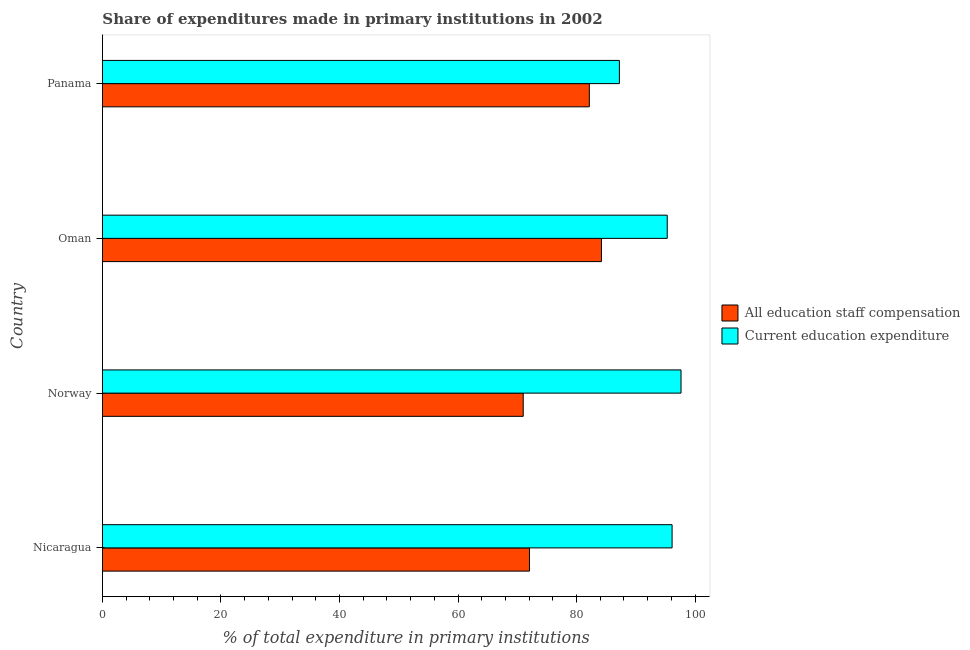How many different coloured bars are there?
Provide a succinct answer. 2. How many groups of bars are there?
Ensure brevity in your answer.  4. How many bars are there on the 4th tick from the top?
Your answer should be compact. 2. What is the label of the 2nd group of bars from the top?
Provide a succinct answer. Oman. What is the expenditure in education in Oman?
Ensure brevity in your answer.  95.31. Across all countries, what is the maximum expenditure in education?
Provide a succinct answer. 97.64. Across all countries, what is the minimum expenditure in staff compensation?
Keep it short and to the point. 71.01. In which country was the expenditure in education minimum?
Your answer should be very brief. Panama. What is the total expenditure in education in the graph?
Ensure brevity in your answer.  376.31. What is the difference between the expenditure in education in Nicaragua and that in Norway?
Offer a terse response. -1.51. What is the difference between the expenditure in education in Panama and the expenditure in staff compensation in Oman?
Provide a short and direct response. 3.03. What is the average expenditure in education per country?
Make the answer very short. 94.08. What is the difference between the expenditure in staff compensation and expenditure in education in Norway?
Your answer should be very brief. -26.63. In how many countries, is the expenditure in education greater than 92 %?
Your response must be concise. 3. What is the ratio of the expenditure in staff compensation in Nicaragua to that in Norway?
Make the answer very short. 1.01. Is the expenditure in staff compensation in Nicaragua less than that in Panama?
Provide a succinct answer. Yes. What is the difference between the highest and the second highest expenditure in education?
Ensure brevity in your answer.  1.51. Is the sum of the expenditure in education in Oman and Panama greater than the maximum expenditure in staff compensation across all countries?
Give a very brief answer. Yes. What does the 1st bar from the top in Panama represents?
Your answer should be very brief. Current education expenditure. What does the 1st bar from the bottom in Norway represents?
Keep it short and to the point. All education staff compensation. Are all the bars in the graph horizontal?
Give a very brief answer. Yes. What is the difference between two consecutive major ticks on the X-axis?
Give a very brief answer. 20. Are the values on the major ticks of X-axis written in scientific E-notation?
Your response must be concise. No. Does the graph contain any zero values?
Ensure brevity in your answer.  No. Does the graph contain grids?
Provide a short and direct response. No. What is the title of the graph?
Your answer should be very brief. Share of expenditures made in primary institutions in 2002. Does "Health Care" appear as one of the legend labels in the graph?
Give a very brief answer. No. What is the label or title of the X-axis?
Offer a terse response. % of total expenditure in primary institutions. What is the % of total expenditure in primary institutions of All education staff compensation in Nicaragua?
Offer a very short reply. 72.06. What is the % of total expenditure in primary institutions of Current education expenditure in Nicaragua?
Keep it short and to the point. 96.13. What is the % of total expenditure in primary institutions in All education staff compensation in Norway?
Provide a short and direct response. 71.01. What is the % of total expenditure in primary institutions in Current education expenditure in Norway?
Your response must be concise. 97.64. What is the % of total expenditure in primary institutions in All education staff compensation in Oman?
Keep it short and to the point. 84.21. What is the % of total expenditure in primary institutions of Current education expenditure in Oman?
Ensure brevity in your answer.  95.31. What is the % of total expenditure in primary institutions of All education staff compensation in Panama?
Keep it short and to the point. 82.16. What is the % of total expenditure in primary institutions in Current education expenditure in Panama?
Provide a succinct answer. 87.24. Across all countries, what is the maximum % of total expenditure in primary institutions of All education staff compensation?
Your response must be concise. 84.21. Across all countries, what is the maximum % of total expenditure in primary institutions of Current education expenditure?
Make the answer very short. 97.64. Across all countries, what is the minimum % of total expenditure in primary institutions of All education staff compensation?
Your answer should be compact. 71.01. Across all countries, what is the minimum % of total expenditure in primary institutions in Current education expenditure?
Your answer should be very brief. 87.24. What is the total % of total expenditure in primary institutions in All education staff compensation in the graph?
Give a very brief answer. 309.44. What is the total % of total expenditure in primary institutions in Current education expenditure in the graph?
Give a very brief answer. 376.31. What is the difference between the % of total expenditure in primary institutions in All education staff compensation in Nicaragua and that in Norway?
Keep it short and to the point. 1.05. What is the difference between the % of total expenditure in primary institutions in Current education expenditure in Nicaragua and that in Norway?
Keep it short and to the point. -1.51. What is the difference between the % of total expenditure in primary institutions in All education staff compensation in Nicaragua and that in Oman?
Make the answer very short. -12.15. What is the difference between the % of total expenditure in primary institutions of Current education expenditure in Nicaragua and that in Oman?
Give a very brief answer. 0.82. What is the difference between the % of total expenditure in primary institutions in All education staff compensation in Nicaragua and that in Panama?
Your answer should be compact. -10.1. What is the difference between the % of total expenditure in primary institutions of Current education expenditure in Nicaragua and that in Panama?
Make the answer very short. 8.9. What is the difference between the % of total expenditure in primary institutions of All education staff compensation in Norway and that in Oman?
Give a very brief answer. -13.2. What is the difference between the % of total expenditure in primary institutions in Current education expenditure in Norway and that in Oman?
Offer a terse response. 2.33. What is the difference between the % of total expenditure in primary institutions of All education staff compensation in Norway and that in Panama?
Offer a terse response. -11.16. What is the difference between the % of total expenditure in primary institutions of Current education expenditure in Norway and that in Panama?
Your answer should be very brief. 10.4. What is the difference between the % of total expenditure in primary institutions of All education staff compensation in Oman and that in Panama?
Give a very brief answer. 2.04. What is the difference between the % of total expenditure in primary institutions in Current education expenditure in Oman and that in Panama?
Keep it short and to the point. 8.07. What is the difference between the % of total expenditure in primary institutions in All education staff compensation in Nicaragua and the % of total expenditure in primary institutions in Current education expenditure in Norway?
Your response must be concise. -25.58. What is the difference between the % of total expenditure in primary institutions in All education staff compensation in Nicaragua and the % of total expenditure in primary institutions in Current education expenditure in Oman?
Give a very brief answer. -23.25. What is the difference between the % of total expenditure in primary institutions in All education staff compensation in Nicaragua and the % of total expenditure in primary institutions in Current education expenditure in Panama?
Your answer should be compact. -15.17. What is the difference between the % of total expenditure in primary institutions in All education staff compensation in Norway and the % of total expenditure in primary institutions in Current education expenditure in Oman?
Make the answer very short. -24.3. What is the difference between the % of total expenditure in primary institutions in All education staff compensation in Norway and the % of total expenditure in primary institutions in Current education expenditure in Panama?
Provide a succinct answer. -16.23. What is the difference between the % of total expenditure in primary institutions of All education staff compensation in Oman and the % of total expenditure in primary institutions of Current education expenditure in Panama?
Ensure brevity in your answer.  -3.03. What is the average % of total expenditure in primary institutions of All education staff compensation per country?
Your answer should be very brief. 77.36. What is the average % of total expenditure in primary institutions in Current education expenditure per country?
Your answer should be very brief. 94.08. What is the difference between the % of total expenditure in primary institutions of All education staff compensation and % of total expenditure in primary institutions of Current education expenditure in Nicaragua?
Provide a short and direct response. -24.07. What is the difference between the % of total expenditure in primary institutions in All education staff compensation and % of total expenditure in primary institutions in Current education expenditure in Norway?
Keep it short and to the point. -26.63. What is the difference between the % of total expenditure in primary institutions of All education staff compensation and % of total expenditure in primary institutions of Current education expenditure in Oman?
Give a very brief answer. -11.1. What is the difference between the % of total expenditure in primary institutions of All education staff compensation and % of total expenditure in primary institutions of Current education expenditure in Panama?
Make the answer very short. -5.07. What is the ratio of the % of total expenditure in primary institutions in All education staff compensation in Nicaragua to that in Norway?
Offer a terse response. 1.01. What is the ratio of the % of total expenditure in primary institutions of Current education expenditure in Nicaragua to that in Norway?
Your response must be concise. 0.98. What is the ratio of the % of total expenditure in primary institutions in All education staff compensation in Nicaragua to that in Oman?
Provide a succinct answer. 0.86. What is the ratio of the % of total expenditure in primary institutions of Current education expenditure in Nicaragua to that in Oman?
Your answer should be compact. 1.01. What is the ratio of the % of total expenditure in primary institutions in All education staff compensation in Nicaragua to that in Panama?
Your answer should be compact. 0.88. What is the ratio of the % of total expenditure in primary institutions in Current education expenditure in Nicaragua to that in Panama?
Your answer should be compact. 1.1. What is the ratio of the % of total expenditure in primary institutions in All education staff compensation in Norway to that in Oman?
Your answer should be very brief. 0.84. What is the ratio of the % of total expenditure in primary institutions of Current education expenditure in Norway to that in Oman?
Provide a short and direct response. 1.02. What is the ratio of the % of total expenditure in primary institutions in All education staff compensation in Norway to that in Panama?
Offer a very short reply. 0.86. What is the ratio of the % of total expenditure in primary institutions of Current education expenditure in Norway to that in Panama?
Ensure brevity in your answer.  1.12. What is the ratio of the % of total expenditure in primary institutions in All education staff compensation in Oman to that in Panama?
Offer a terse response. 1.02. What is the ratio of the % of total expenditure in primary institutions of Current education expenditure in Oman to that in Panama?
Your answer should be compact. 1.09. What is the difference between the highest and the second highest % of total expenditure in primary institutions in All education staff compensation?
Your answer should be compact. 2.04. What is the difference between the highest and the second highest % of total expenditure in primary institutions in Current education expenditure?
Your response must be concise. 1.51. What is the difference between the highest and the lowest % of total expenditure in primary institutions in All education staff compensation?
Your answer should be compact. 13.2. What is the difference between the highest and the lowest % of total expenditure in primary institutions of Current education expenditure?
Provide a succinct answer. 10.4. 